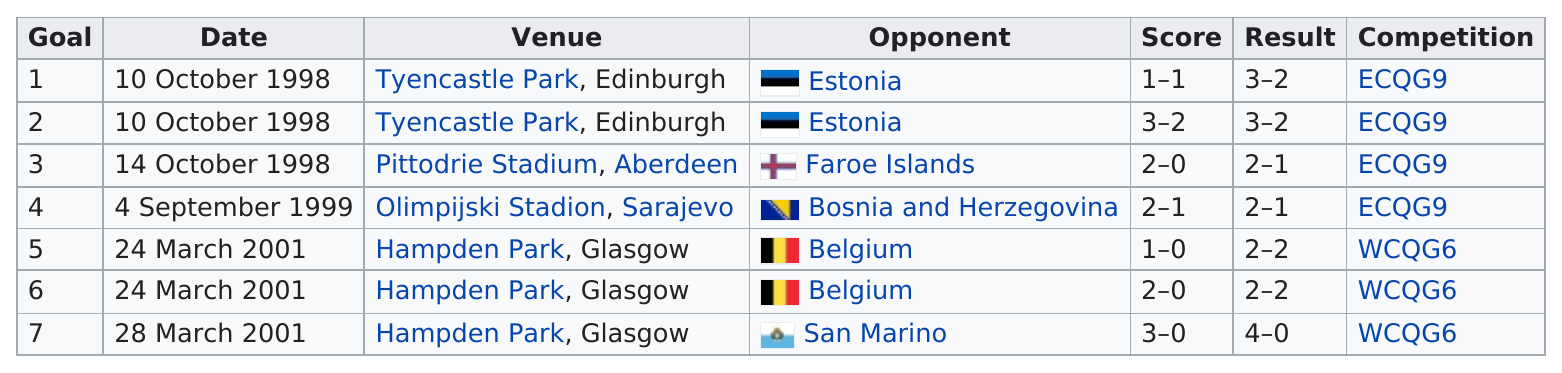Point out several critical features in this image. At Hampden Park in Glasgow, a total of 3 games were played. In a specific game, the least amount of goals scored was only one goal. Billy Dodd played his last opponent in his international career against San Marino, a small country located in southern Europe. The preceding game was against Estonia, and the next one was against the Faroe Islands. As of my knowledge cutoff date, Billy Dodds has played a total of three times at Hampden Park. 